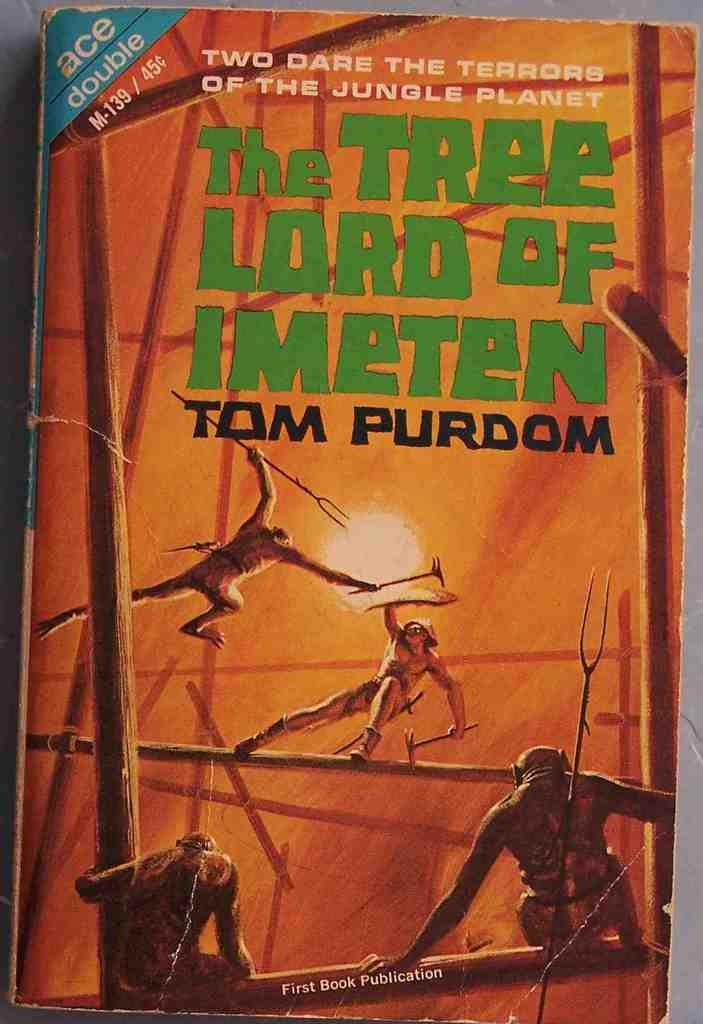What is featured on the poster in the image? There is a poster in the image, and it has people depicted on it. What else can be seen on the poster besides the people? There is text on the poster. What type of objects are present in the image? There are wooden poles and some other objects in the image. Can you tell me how many marks are on the poster? There is no mention of marks on the poster in the provided facts, so it cannot be determined from the image. What type of bean is being used to hold up the wooden poles in the image? There are no beans present in the image, and the wooden poles are not being held up by any beans. 